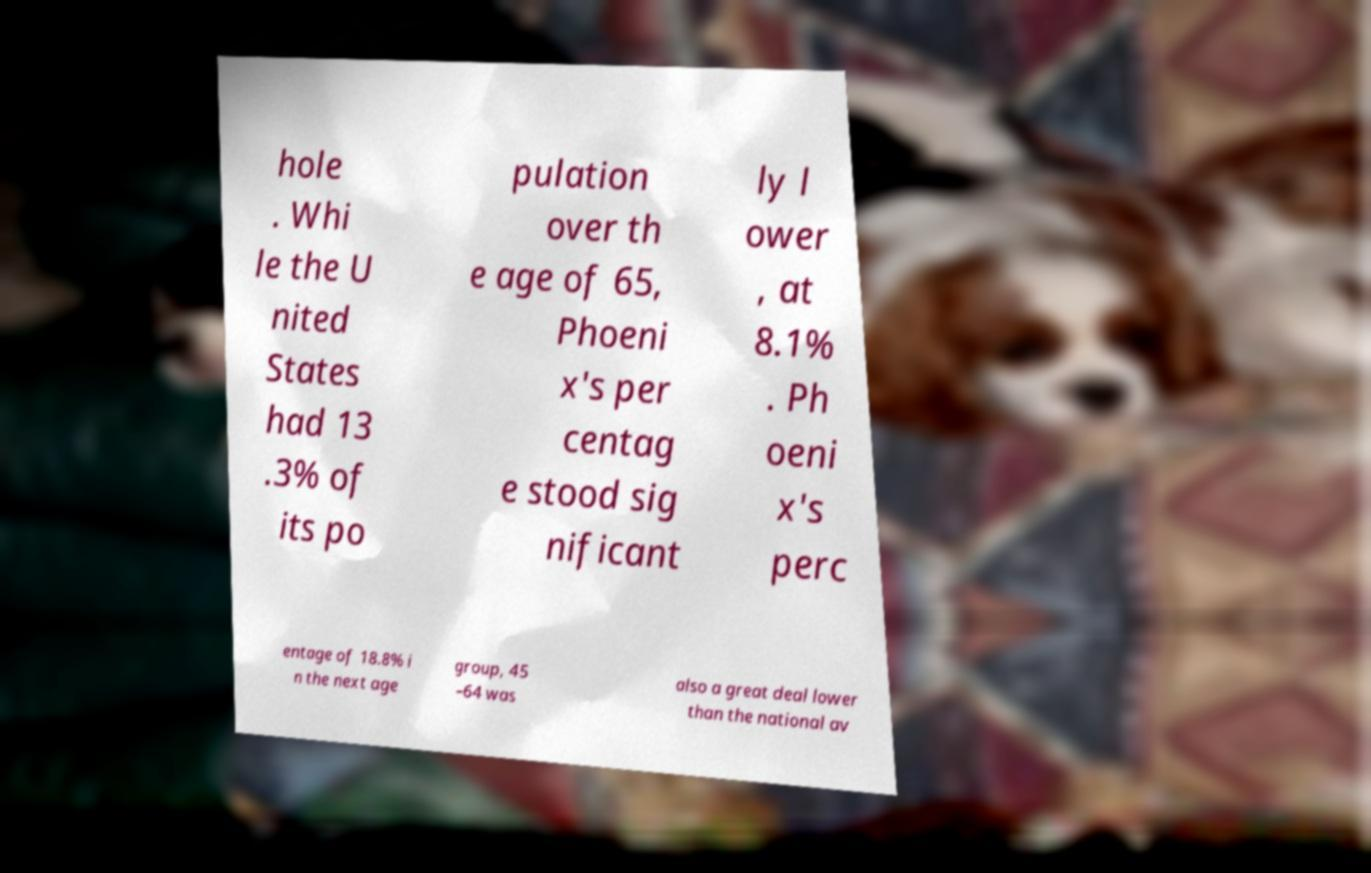What messages or text are displayed in this image? I need them in a readable, typed format. hole . Whi le the U nited States had 13 .3% of its po pulation over th e age of 65, Phoeni x's per centag e stood sig nificant ly l ower , at 8.1% . Ph oeni x's perc entage of 18.8% i n the next age group, 45 –64 was also a great deal lower than the national av 